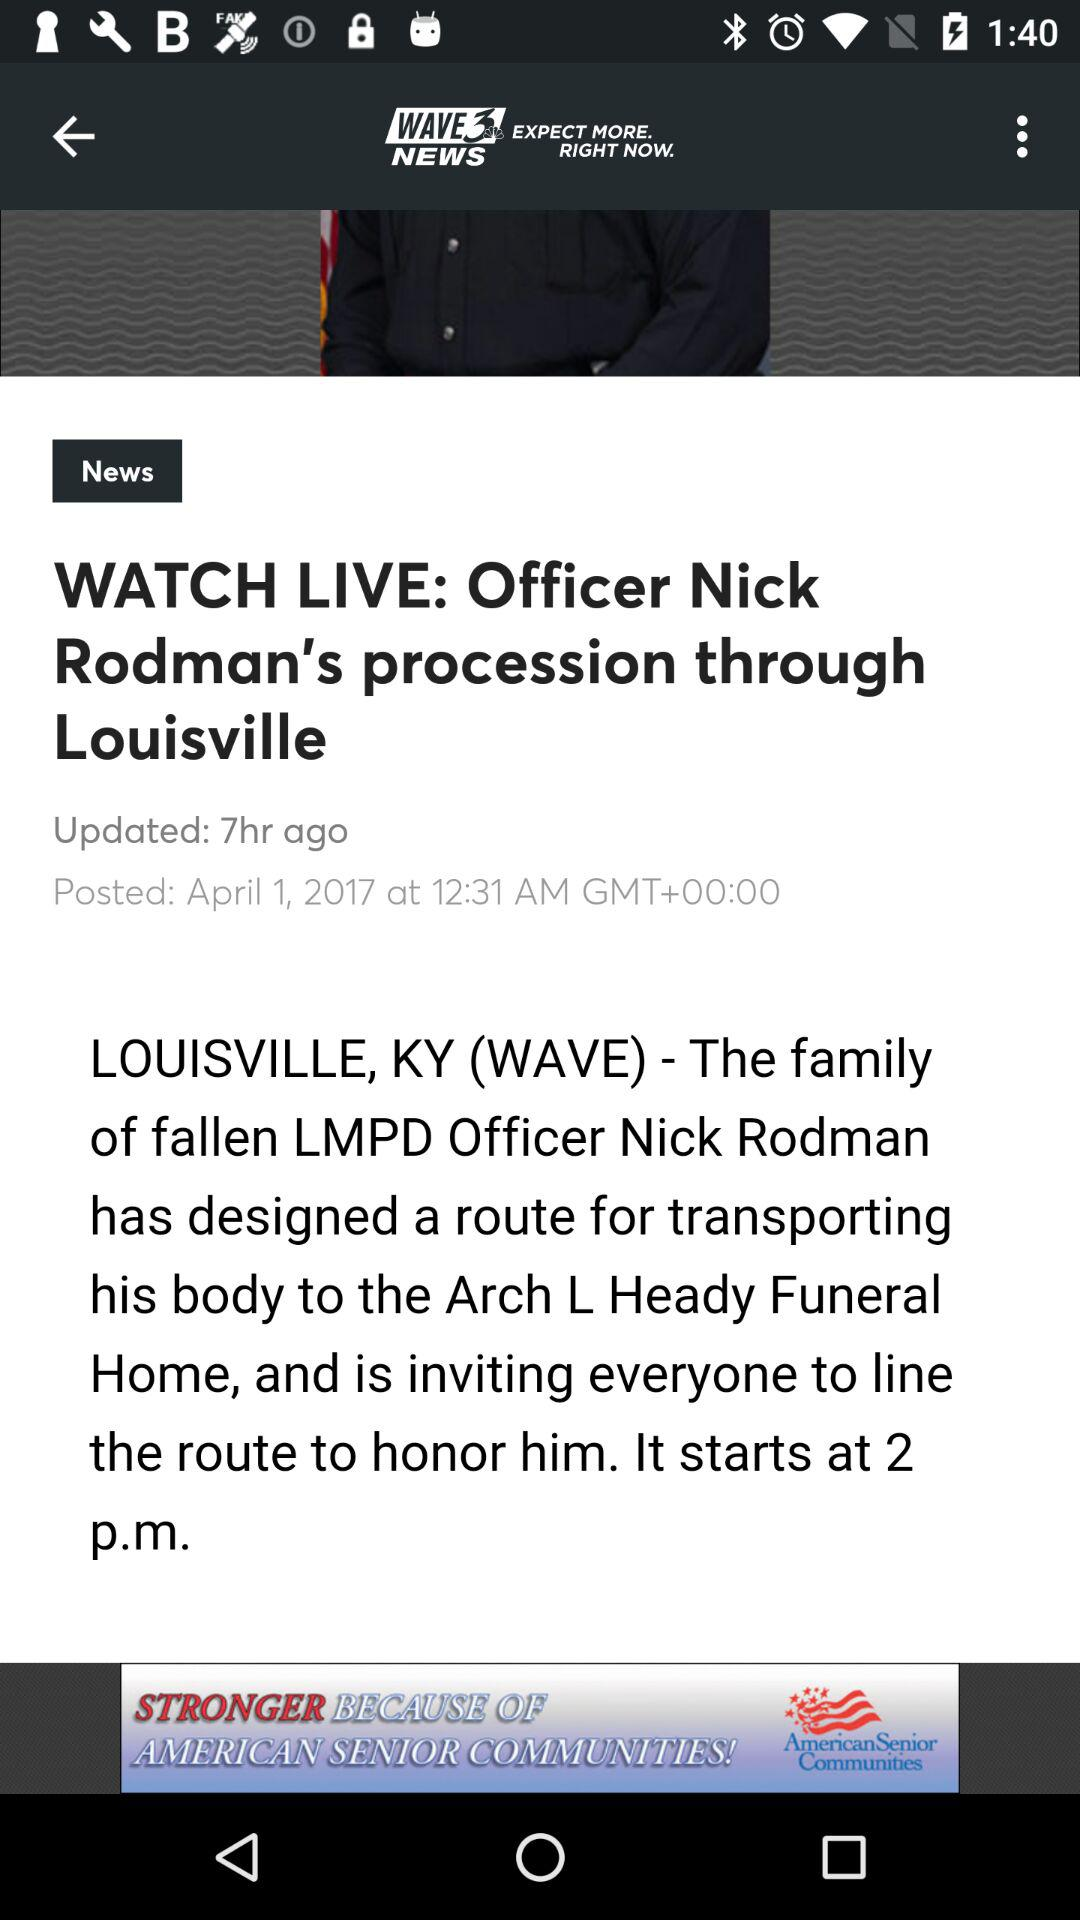How many hours ago was the article updated?
Answer the question using a single word or phrase. 7 